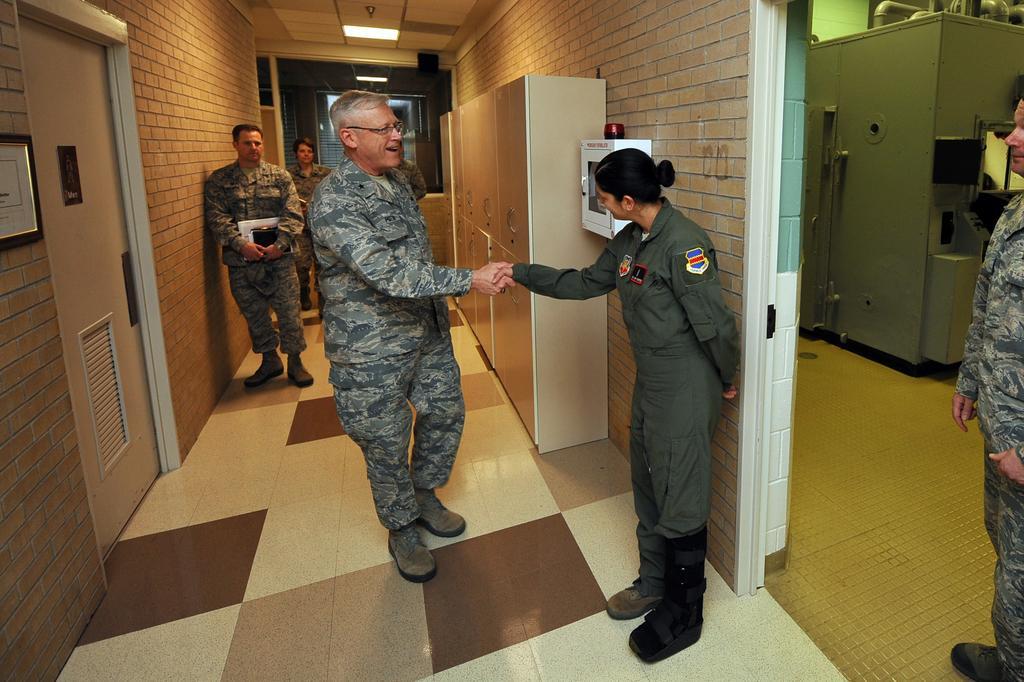Describe this image in one or two sentences. In this image there are two people shaking hands, behind them there are two other people standing in the corridor, beside them there is a locker, first aid kit, photo frame on the wall and there is a closed door, on the right side of the image there is a person standing, behind the person there is machinery equipment. 